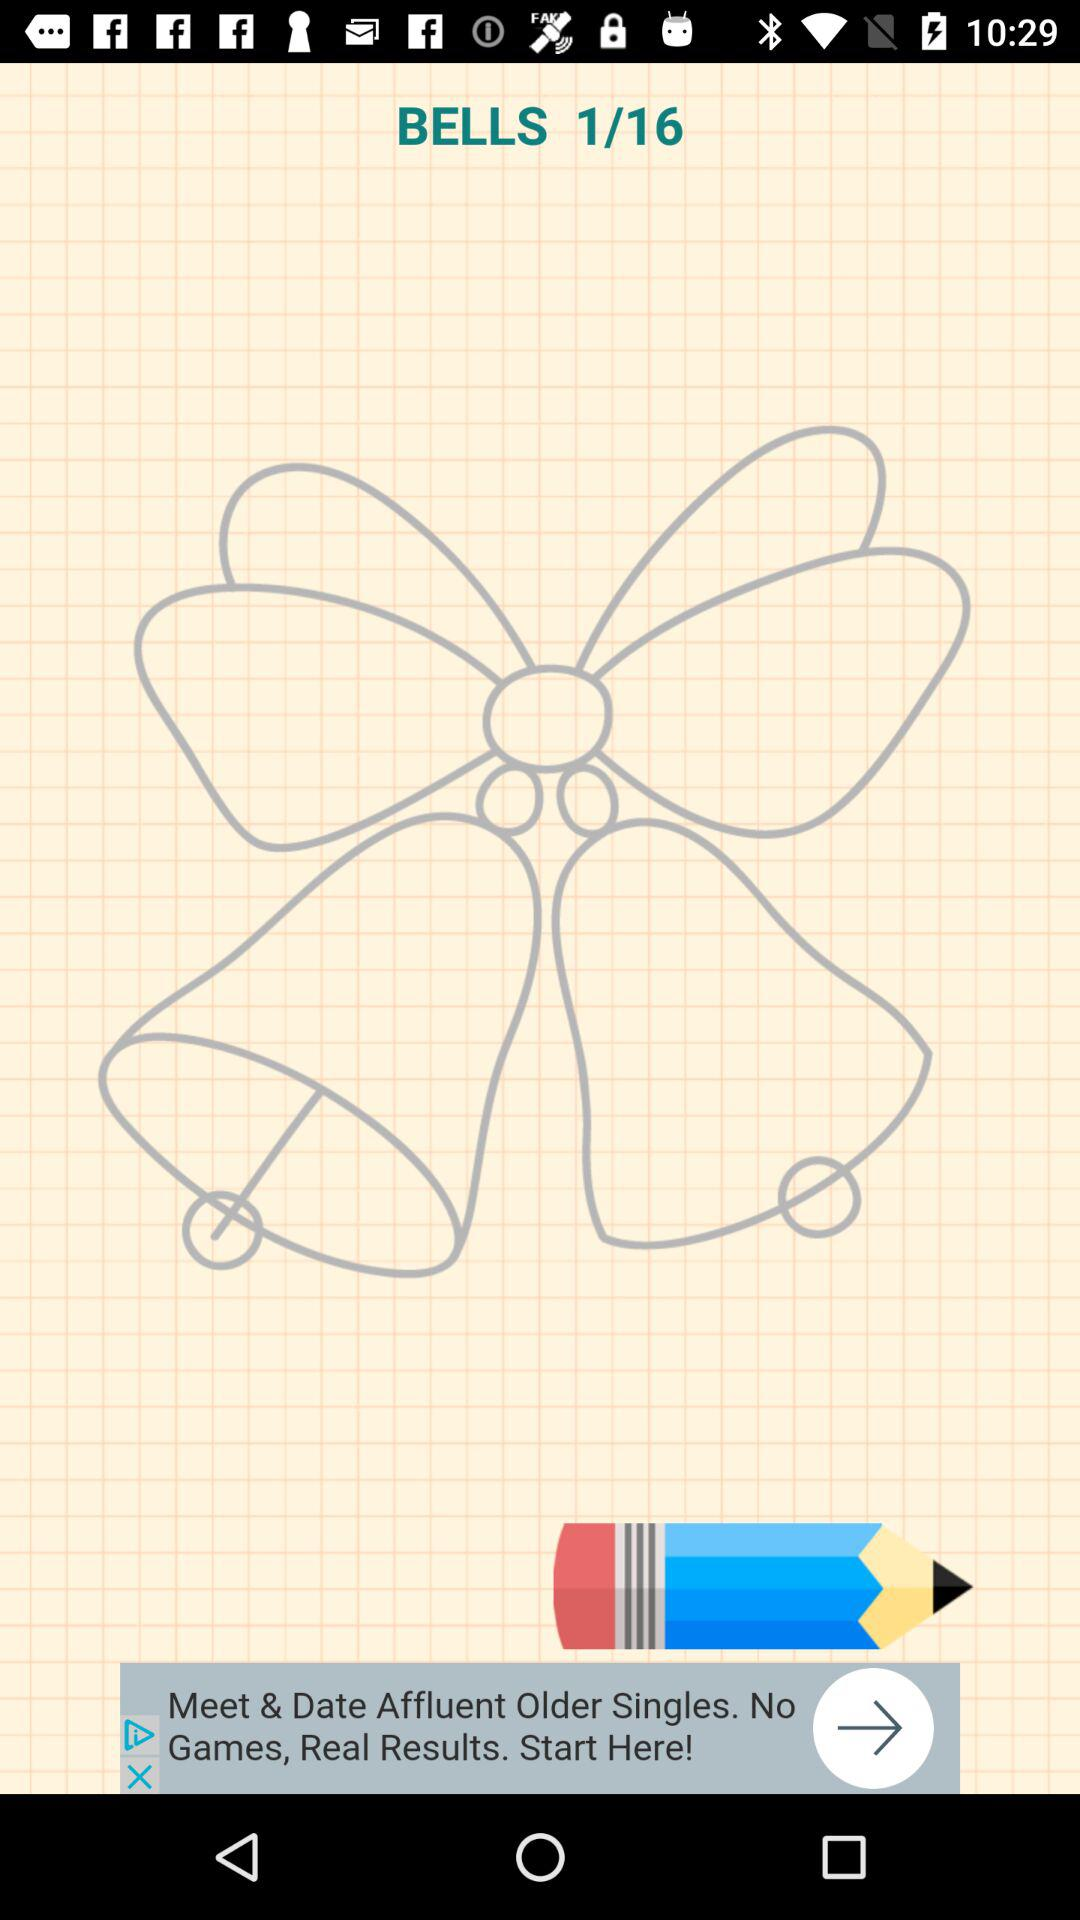What is the name of the current image? The name of the current image is "BELLS". 